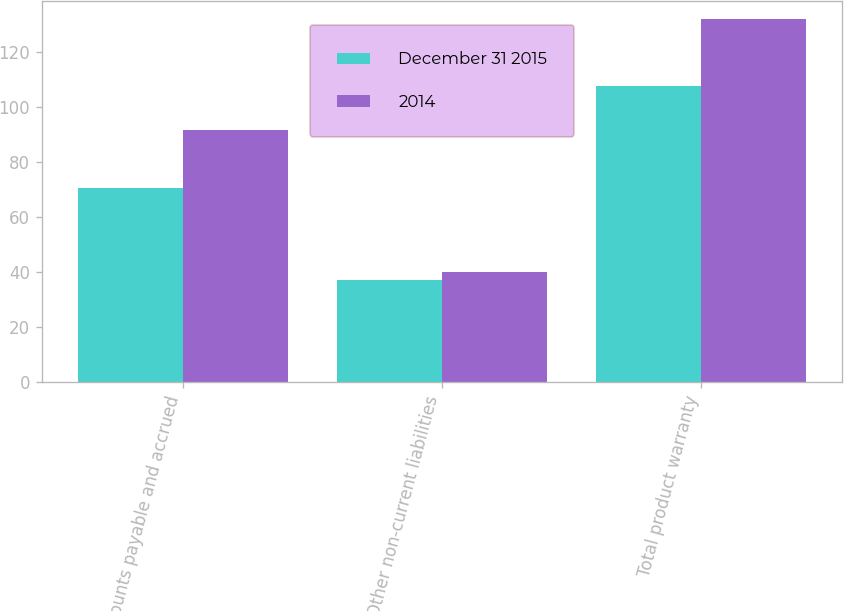Convert chart. <chart><loc_0><loc_0><loc_500><loc_500><stacked_bar_chart><ecel><fcel>Accounts payable and accrued<fcel>Other non-current liabilities<fcel>Total product warranty<nl><fcel>December 31 2015<fcel>70.6<fcel>37.3<fcel>107.9<nl><fcel>2014<fcel>91.9<fcel>40.1<fcel>132<nl></chart> 